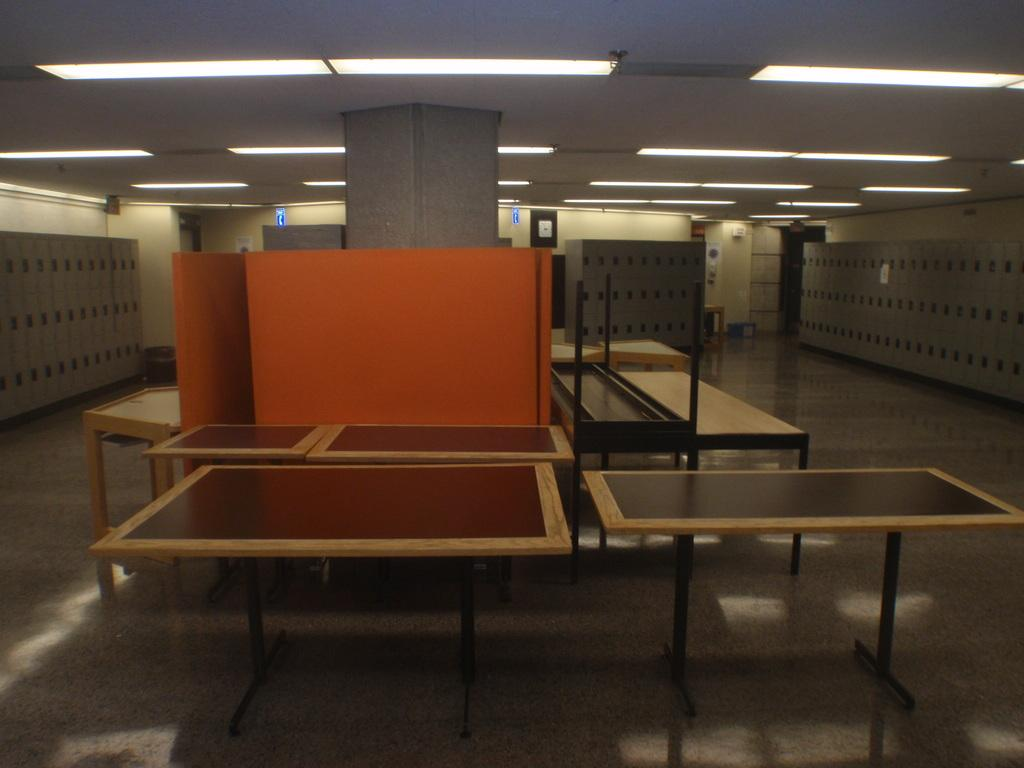What type of furniture is present in the image? There are tables in the image. What other objects can be seen in the image? There are lockers in the image. What can be used for illumination in the image? There are lights in the image. Can you see a cat using the brake on one of the tables in the image? There is no cat or brake present in the image. 